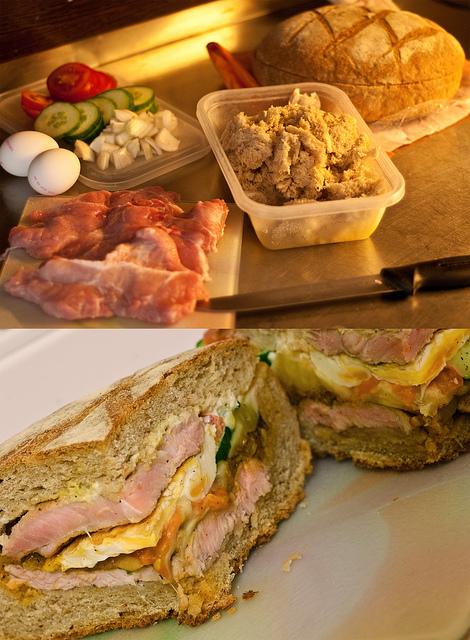What kind of sandwich is this?
Concise answer only. Ham and egg. Are there vegetables in the picture?
Concise answer only. Yes. What is this picture describing?
Quick response, please. Food. Does this look like American cuisine?
Give a very brief answer. Yes. 